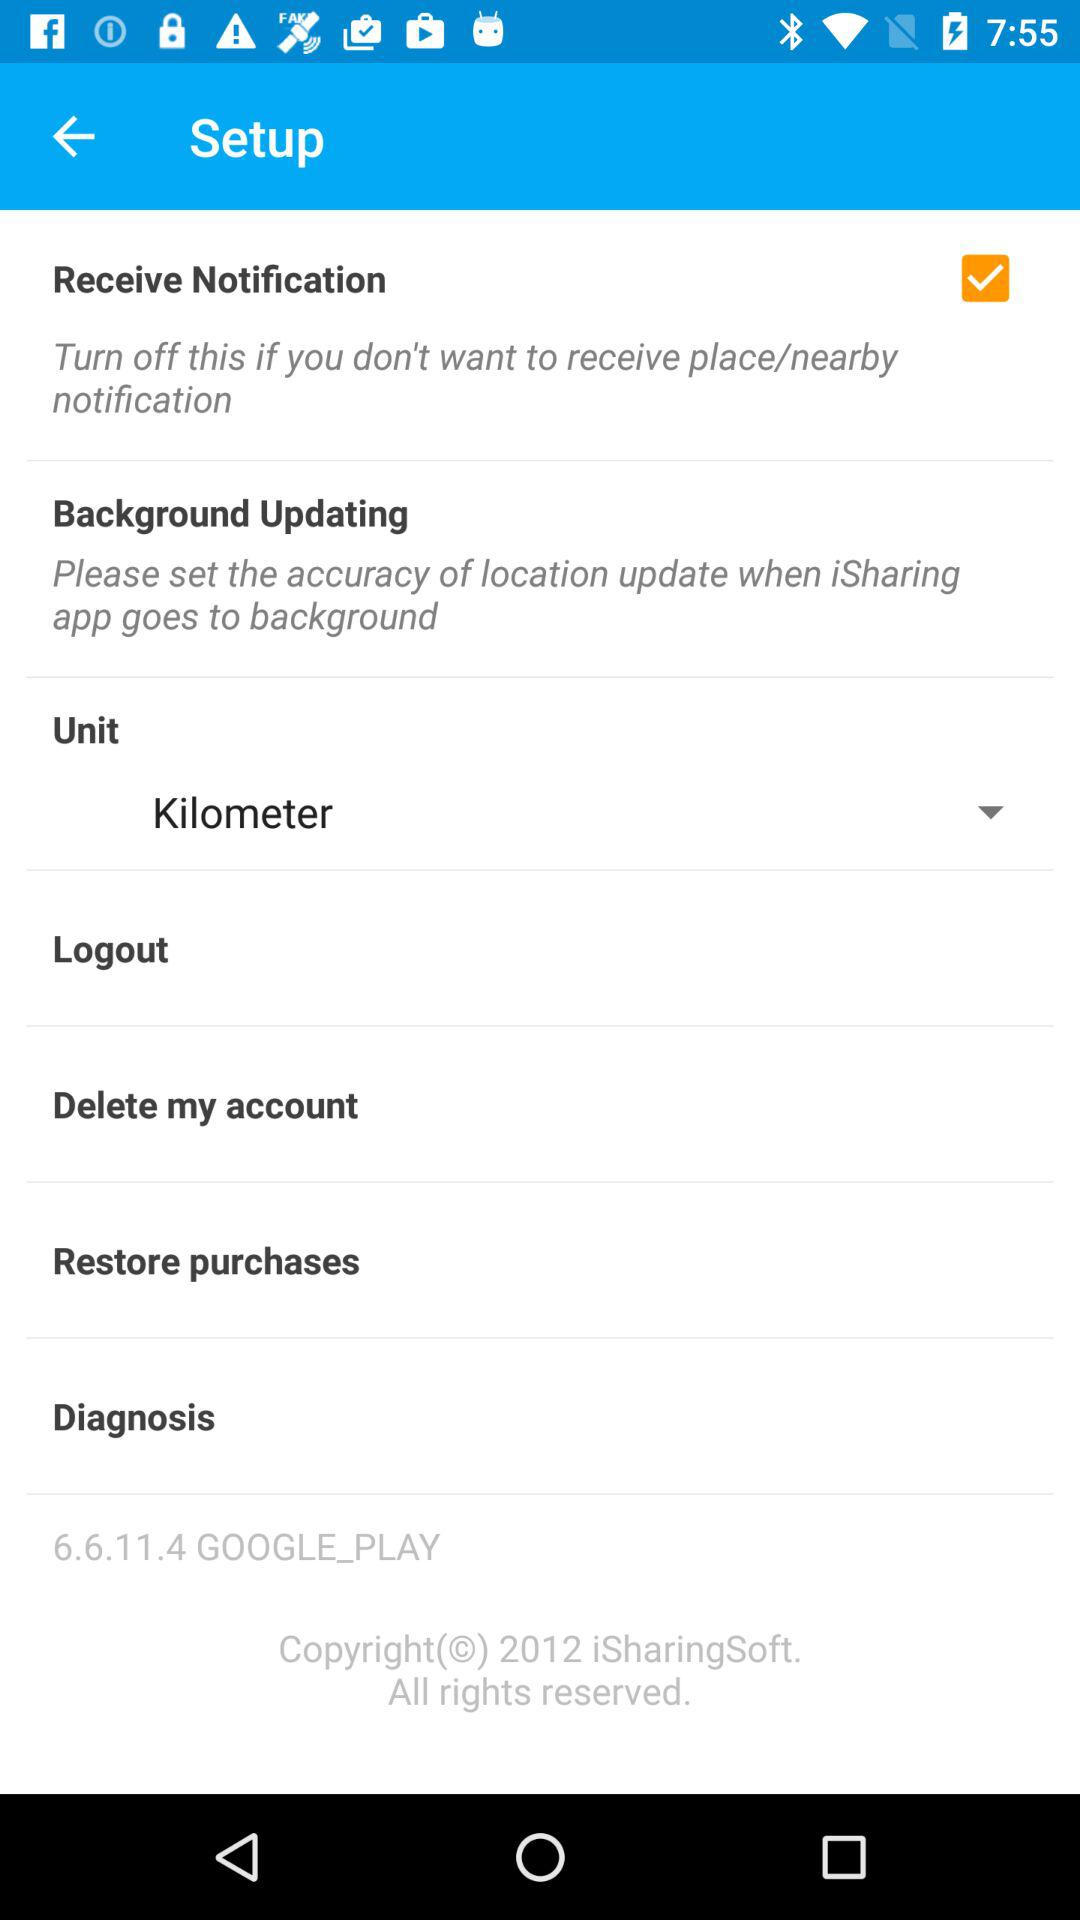What is the version of "GOOGLE_PLAY"? The version is 6.6.11.4. 